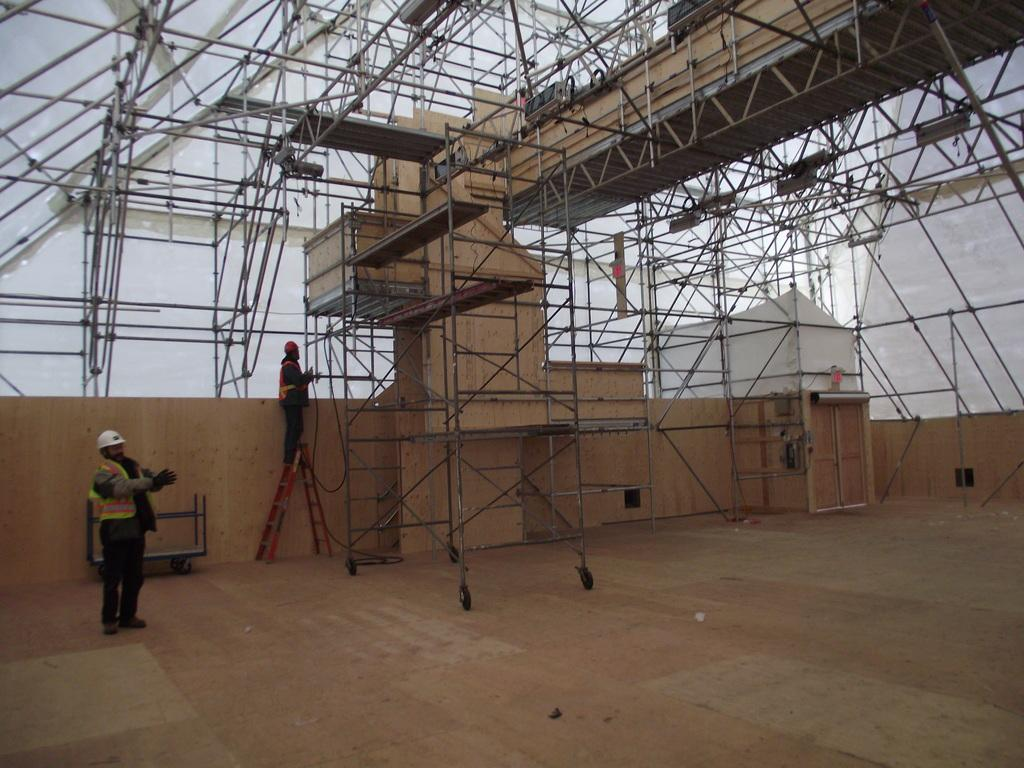How many people are in the image? There are two people in the image. What is one person doing in the image? One person is standing on a ladder. What can be seen in the background of the image? There is a beam visible in the background of the image. What type of marble is being used to decorate the ladder in the image? There is no marble present in the image, and the ladder is not being decorated. 